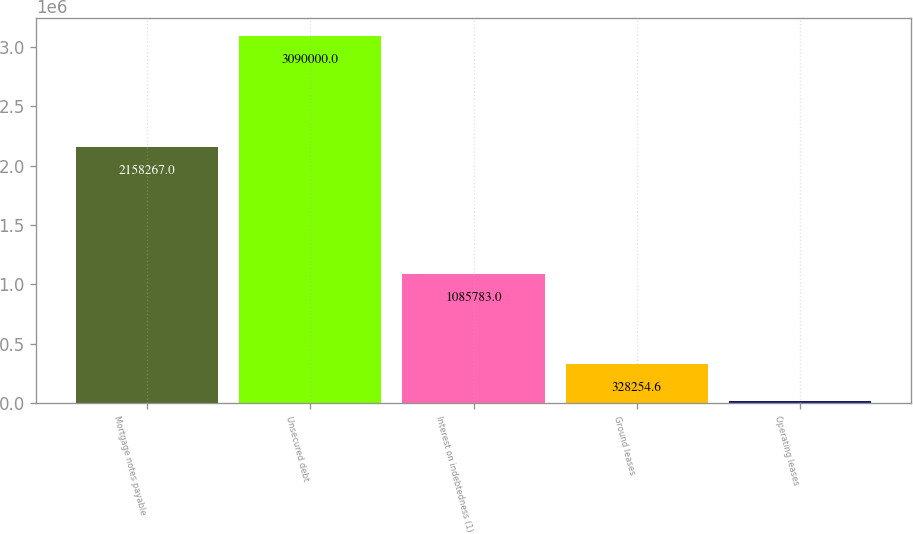Convert chart. <chart><loc_0><loc_0><loc_500><loc_500><bar_chart><fcel>Mortgage notes payable<fcel>Unsecured debt<fcel>Interest on indebtedness (1)<fcel>Ground leases<fcel>Operating leases<nl><fcel>2.15827e+06<fcel>3.09e+06<fcel>1.08578e+06<fcel>328255<fcel>21394<nl></chart> 